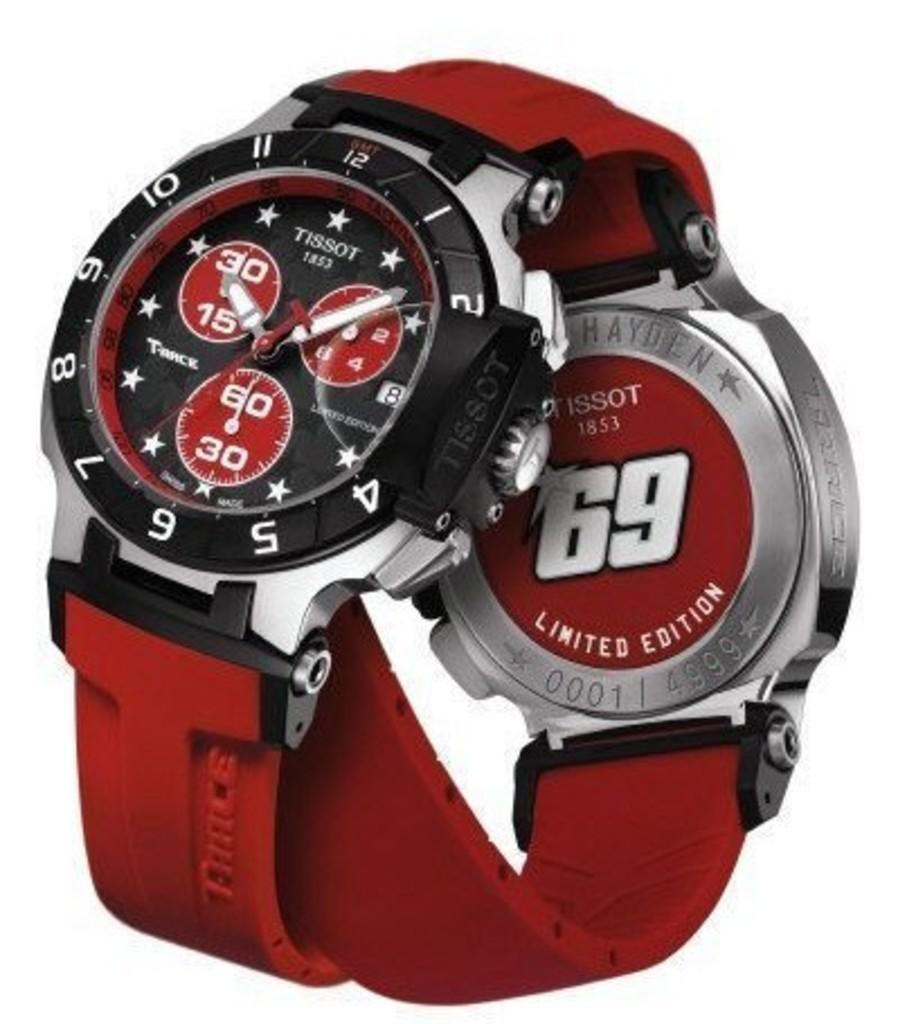<image>
Render a clear and concise summary of the photo. A limited edition Tissot watch is albeled with the number 69 on the back of it. 